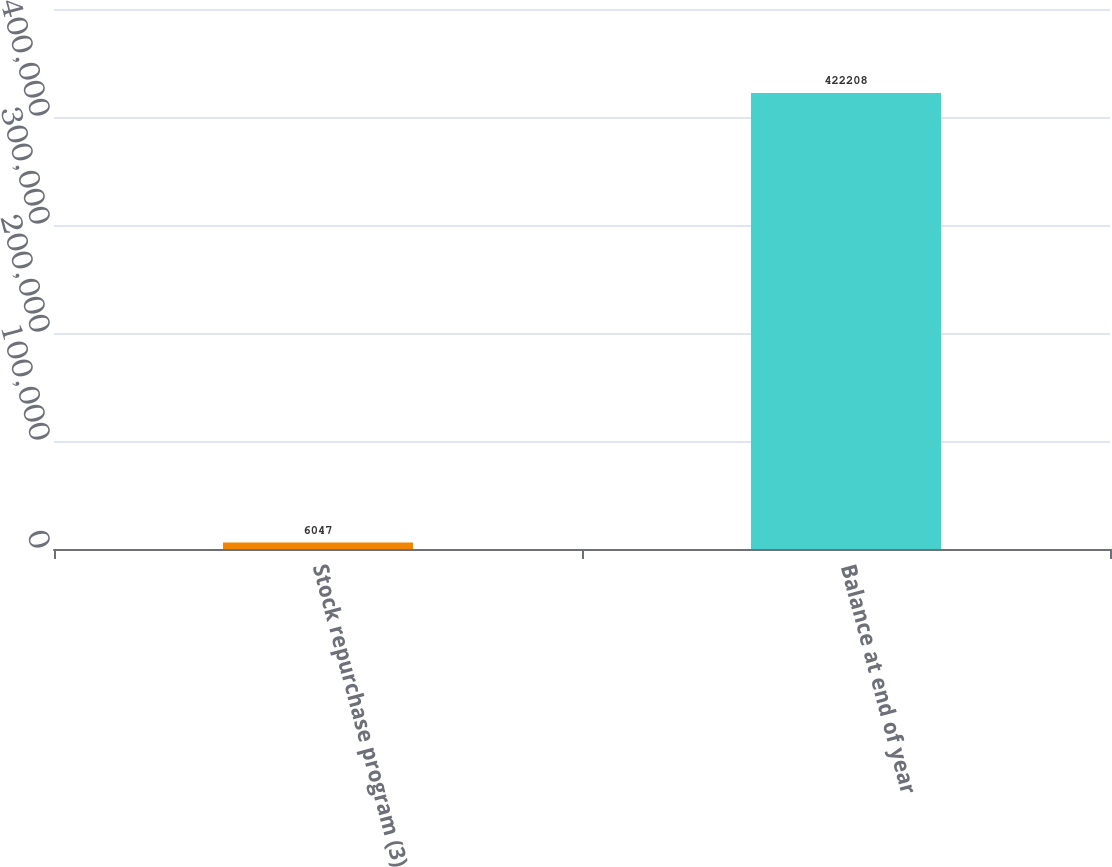Convert chart. <chart><loc_0><loc_0><loc_500><loc_500><bar_chart><fcel>Stock repurchase program (3)<fcel>Balance at end of year<nl><fcel>6047<fcel>422208<nl></chart> 